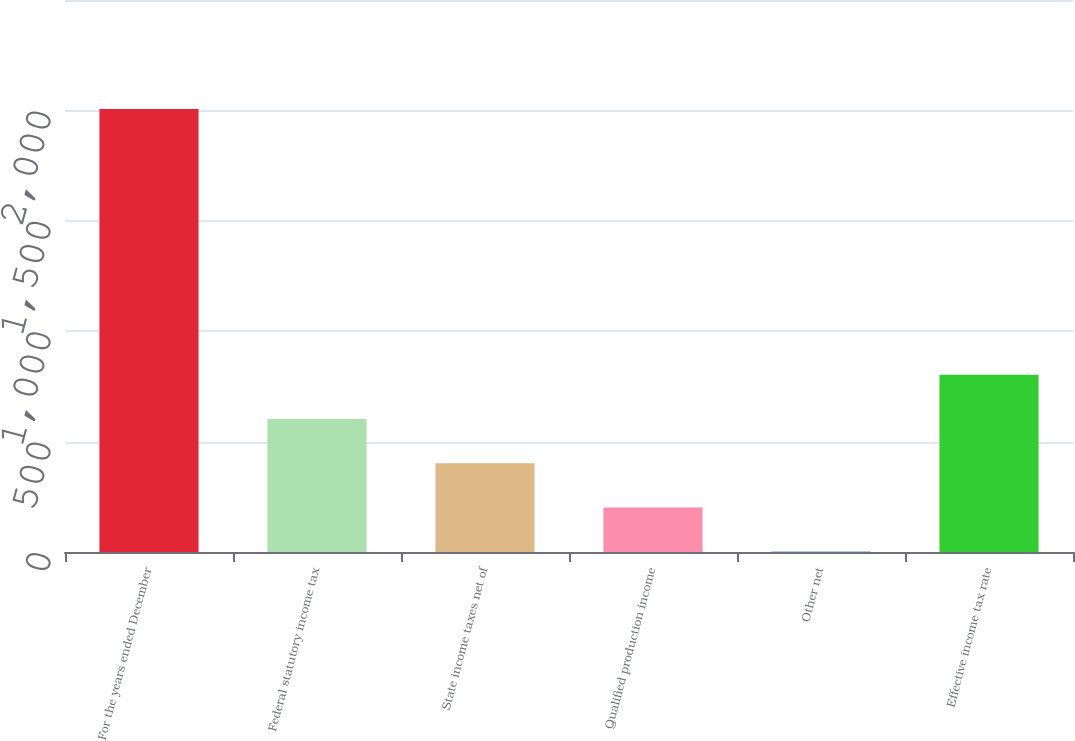Convert chart. <chart><loc_0><loc_0><loc_500><loc_500><bar_chart><fcel>For the years ended December<fcel>Federal statutory income tax<fcel>State income taxes net of<fcel>Qualified production income<fcel>Other net<fcel>Effective income tax rate<nl><fcel>2006<fcel>602.29<fcel>401.76<fcel>201.23<fcel>0.7<fcel>802.82<nl></chart> 